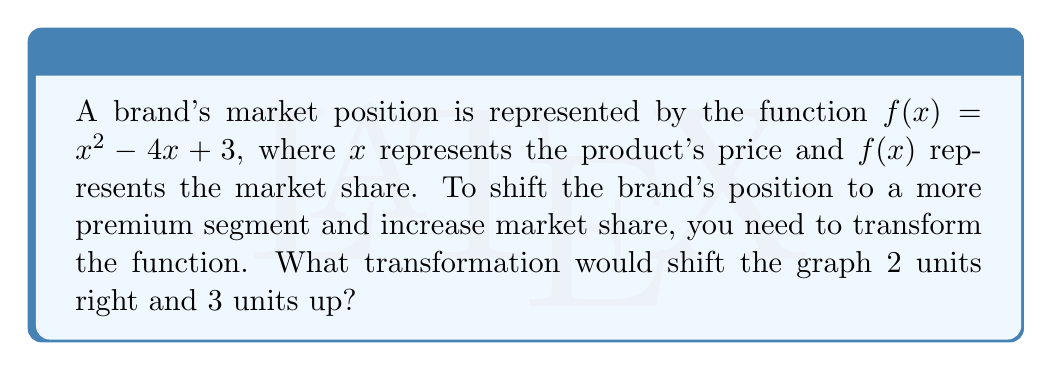Provide a solution to this math problem. To solve this problem, we need to apply two transformations to the original function:

1. Shift right by 2 units: Replace $x$ with $(x - 2)$
   $f(x) = (x - 2)^2 - 4(x - 2) + 3$

2. Shift up by 3 units: Add 3 to the entire function
   $f(x) = (x - 2)^2 - 4(x - 2) + 3 + 3$

Simplifying:
$f(x) = (x - 2)^2 - 4(x - 2) + 6$
$f(x) = x^2 - 4x + 4 - 4x + 8 + 6$
$f(x) = x^2 - 8x + 18$

The resulting function $f(x) = x^2 - 8x + 18$ represents the brand's new market position after the transformation.

In function notation, this transformation can be written as:
$g(x) = f(x - 2) + 3$

Where $g(x)$ is the new transformed function.
Answer: $g(x) = f(x - 2) + 3$ 